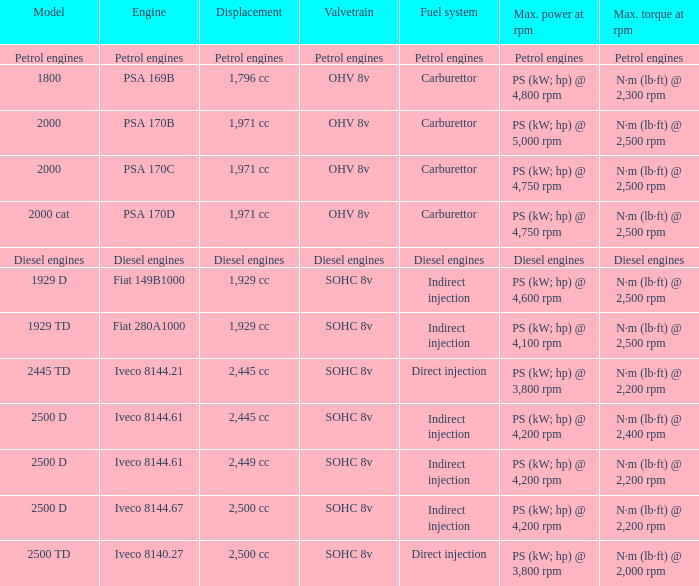What is the maximum torque that has 2,445 CC Displacement, and an Iveco 8144.61 engine? N·m (lb·ft) @ 2,400 rpm. 